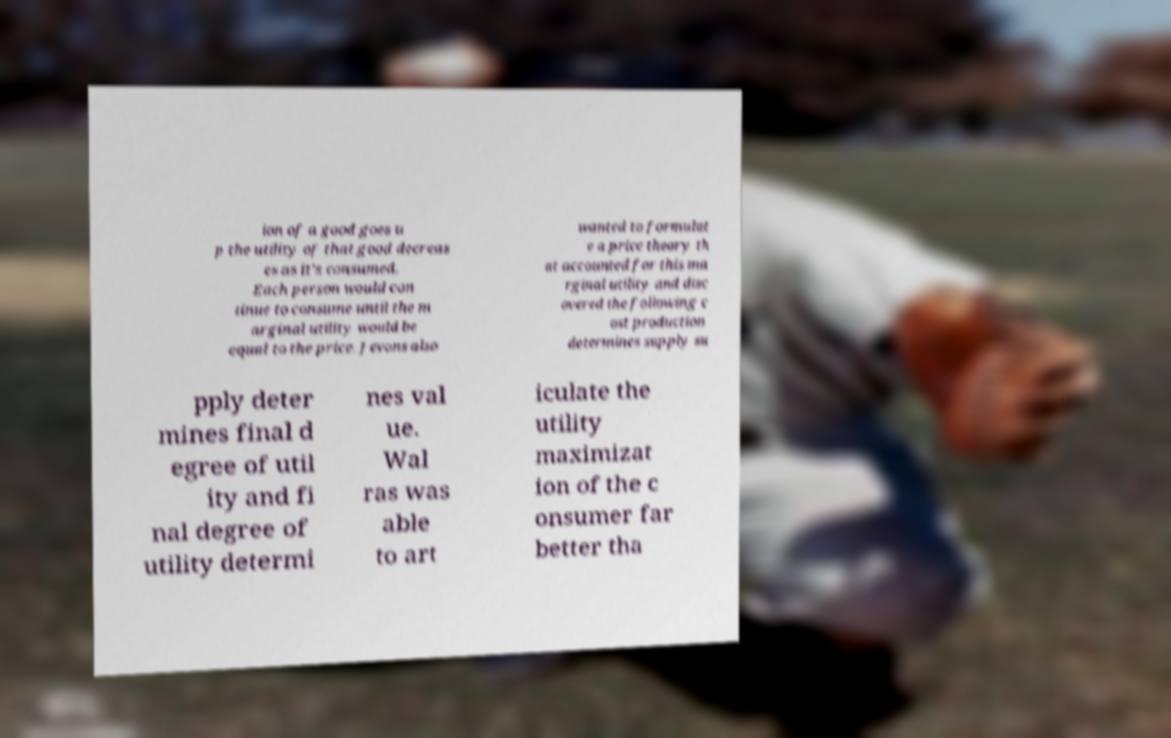For documentation purposes, I need the text within this image transcribed. Could you provide that? ion of a good goes u p the utility of that good decreas es as it’s consumed. Each person would con tinue to consume until the m arginal utility would be equal to the price. Jevons also wanted to formulat e a price theory th at accounted for this ma rginal utility and disc overed the following c ost production determines supply su pply deter mines final d egree of util ity and fi nal degree of utility determi nes val ue. Wal ras was able to art iculate the utility maximizat ion of the c onsumer far better tha 